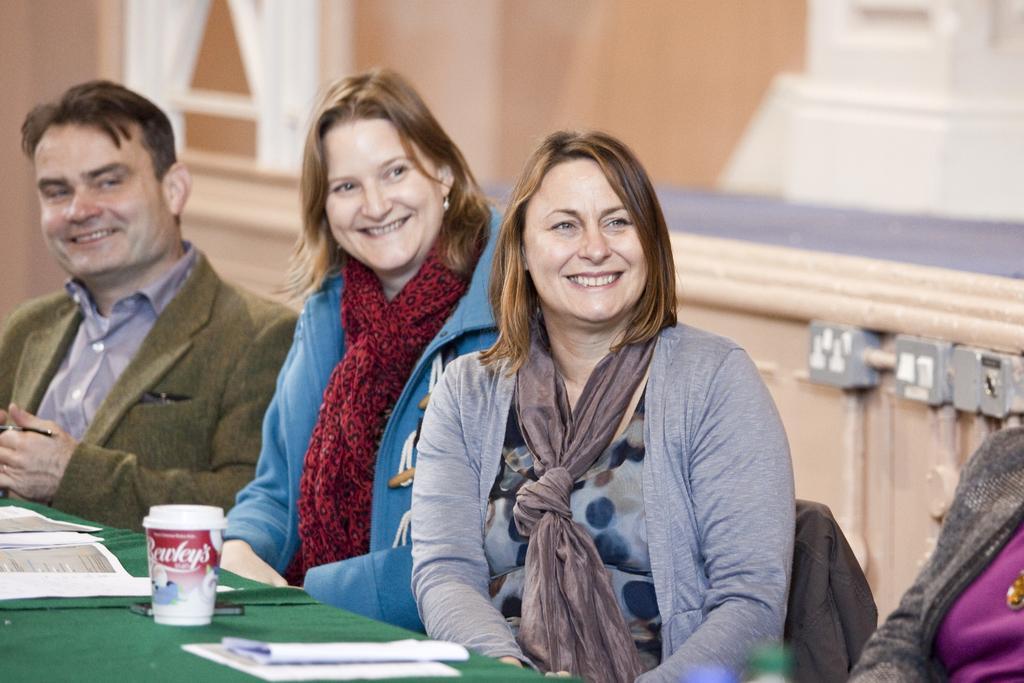Could you give a brief overview of what you see in this image? In this image I can see people sitting on chairs in front of a table. These people are smiling. On the table I can see a glass, papers and other objects. In the background I can see a wall and other objects. The background of the image is blurred. 